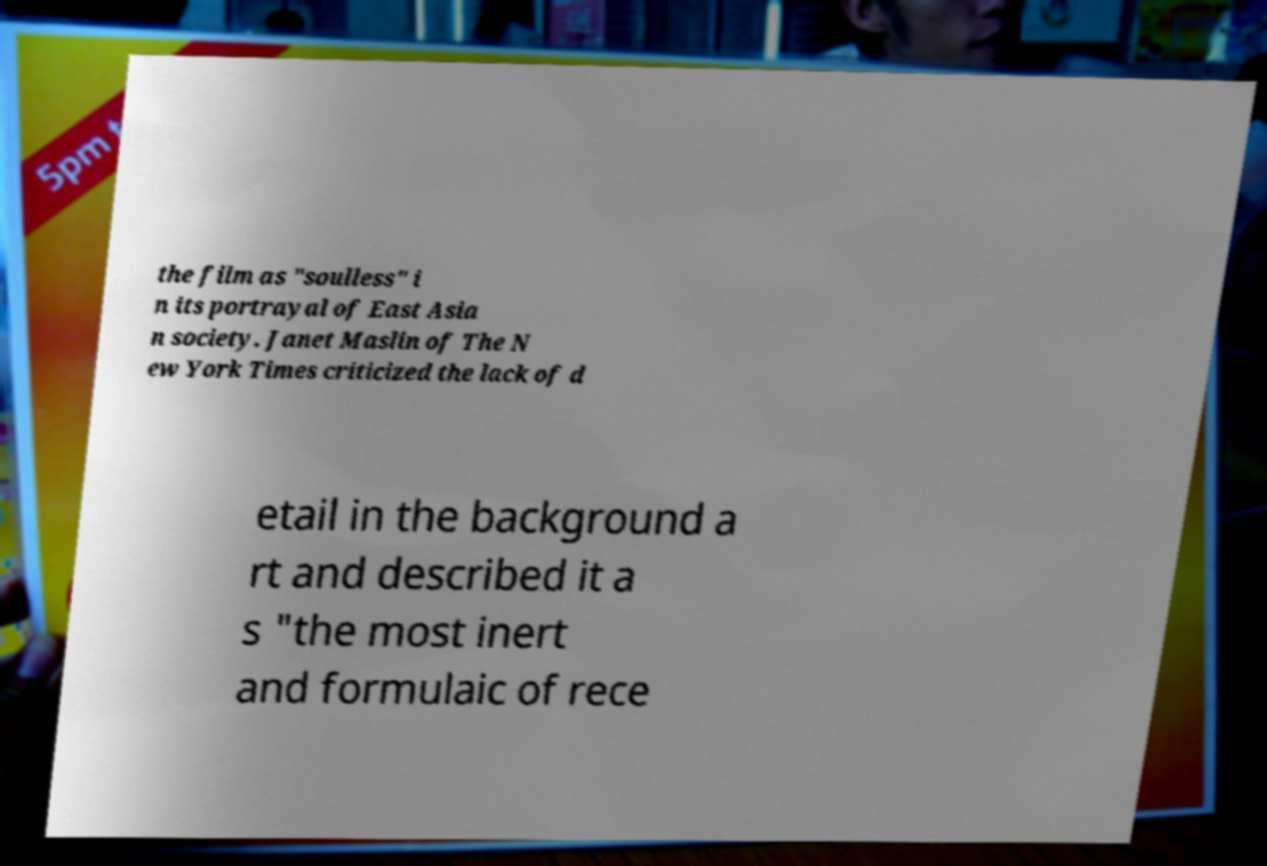Please read and relay the text visible in this image. What does it say? the film as "soulless" i n its portrayal of East Asia n society. Janet Maslin of The N ew York Times criticized the lack of d etail in the background a rt and described it a s "the most inert and formulaic of rece 